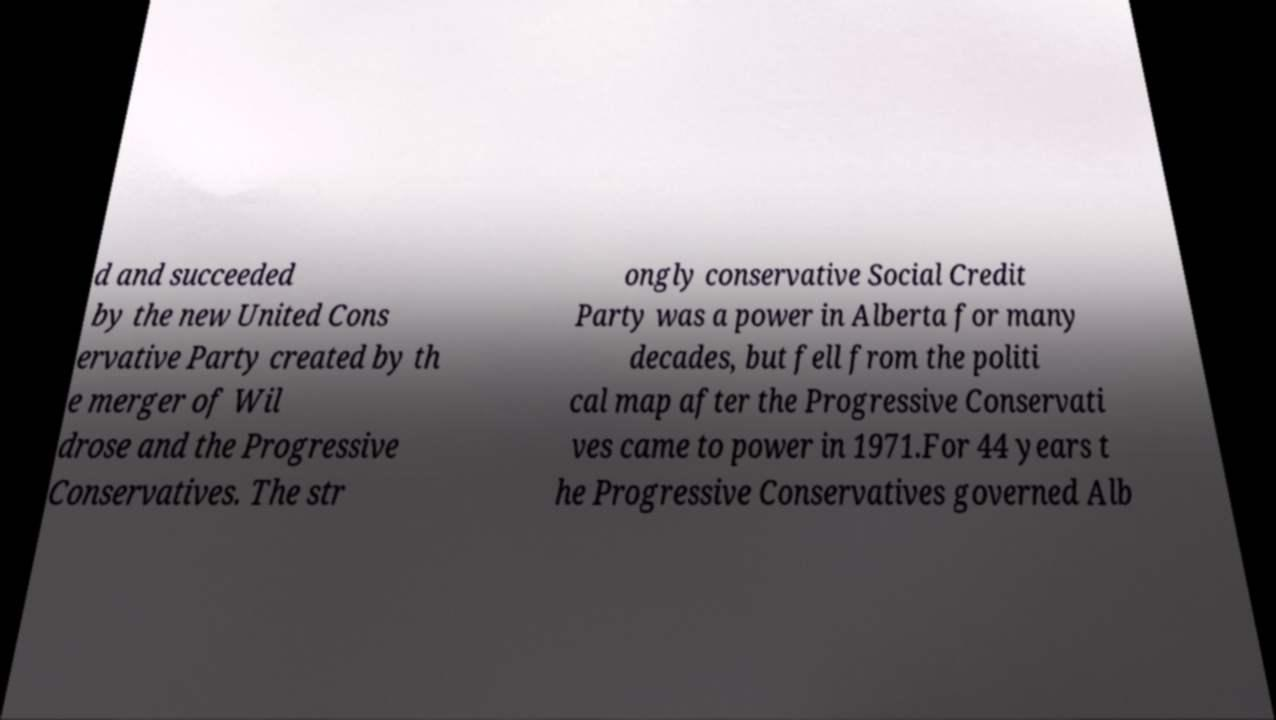Please identify and transcribe the text found in this image. d and succeeded by the new United Cons ervative Party created by th e merger of Wil drose and the Progressive Conservatives. The str ongly conservative Social Credit Party was a power in Alberta for many decades, but fell from the politi cal map after the Progressive Conservati ves came to power in 1971.For 44 years t he Progressive Conservatives governed Alb 